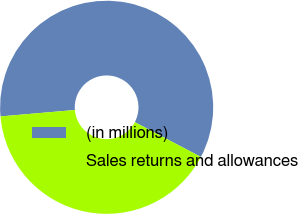<chart> <loc_0><loc_0><loc_500><loc_500><pie_chart><fcel>(in millions)<fcel>Sales returns and allowances<nl><fcel>59.08%<fcel>40.92%<nl></chart> 